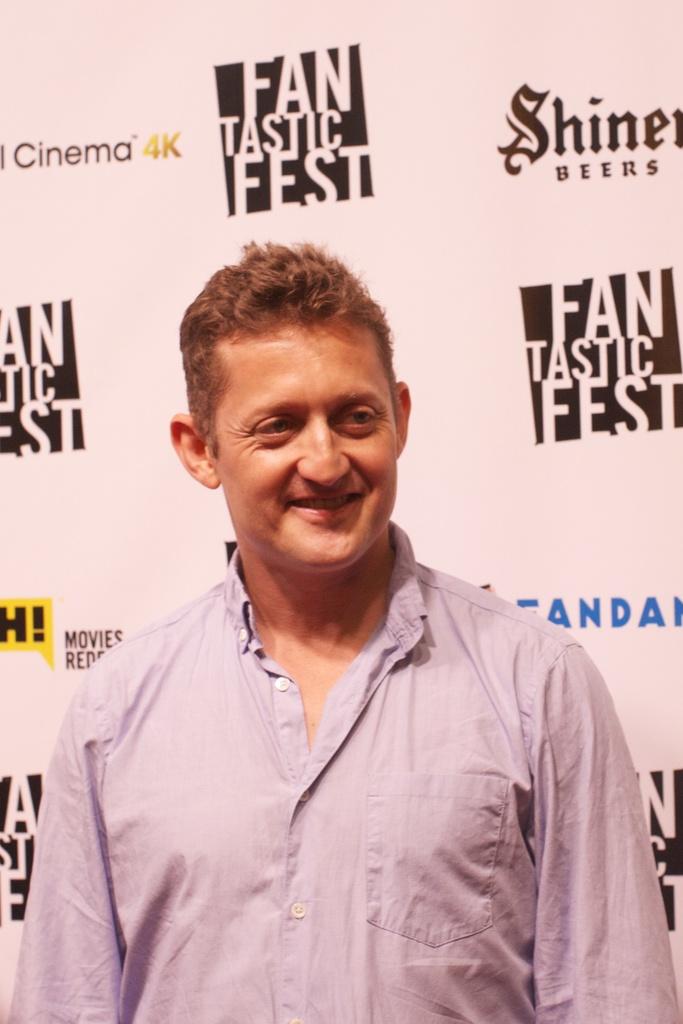What kind of fest?
Offer a terse response. Fantastic. What type of beverage company is a sponsor?
Give a very brief answer. Shiner beers. 